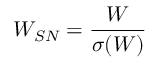<formula> <loc_0><loc_0><loc_500><loc_500>W _ { S N } = \frac { W } { \sigma ( W ) }</formula> 